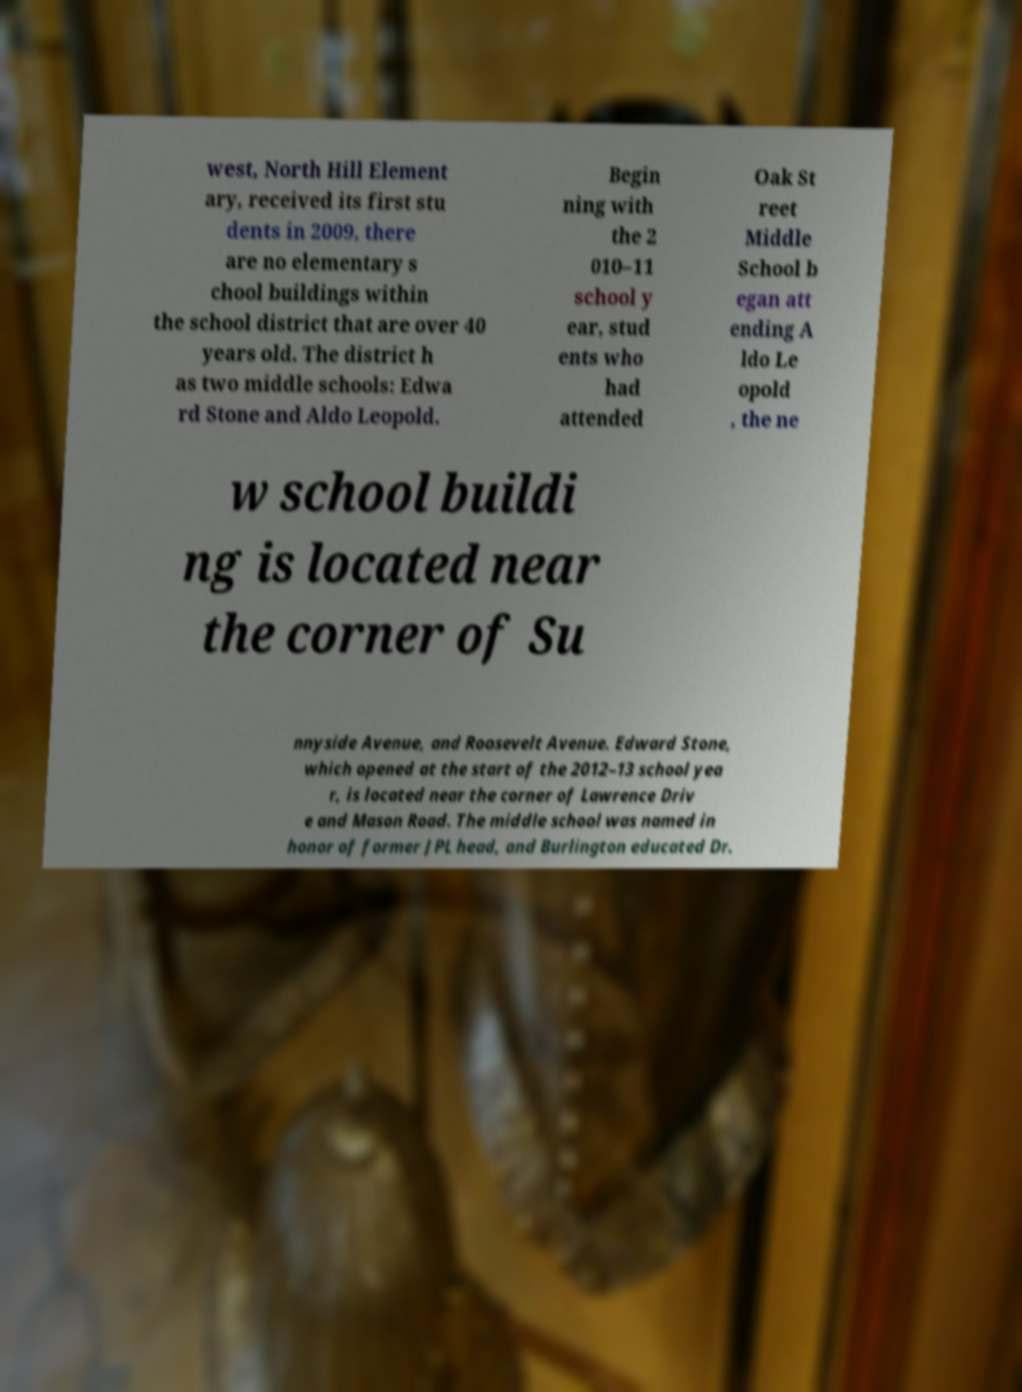Please read and relay the text visible in this image. What does it say? west, North Hill Element ary, received its first stu dents in 2009, there are no elementary s chool buildings within the school district that are over 40 years old. The district h as two middle schools: Edwa rd Stone and Aldo Leopold. Begin ning with the 2 010–11 school y ear, stud ents who had attended Oak St reet Middle School b egan att ending A ldo Le opold , the ne w school buildi ng is located near the corner of Su nnyside Avenue, and Roosevelt Avenue. Edward Stone, which opened at the start of the 2012–13 school yea r, is located near the corner of Lawrence Driv e and Mason Road. The middle school was named in honor of former JPL head, and Burlington educated Dr. 